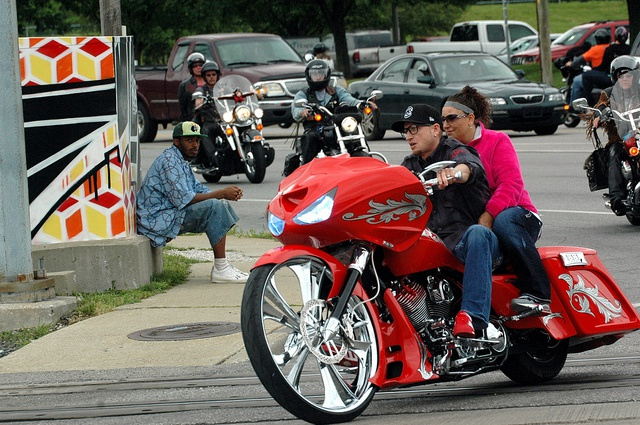Describe the objects in this image and their specific colors. I can see motorcycle in gray, black, maroon, and white tones, people in gray, black, navy, and blue tones, car in gray, black, and darkgray tones, truck in gray, black, and darkgray tones, and car in gray, black, and darkgray tones in this image. 